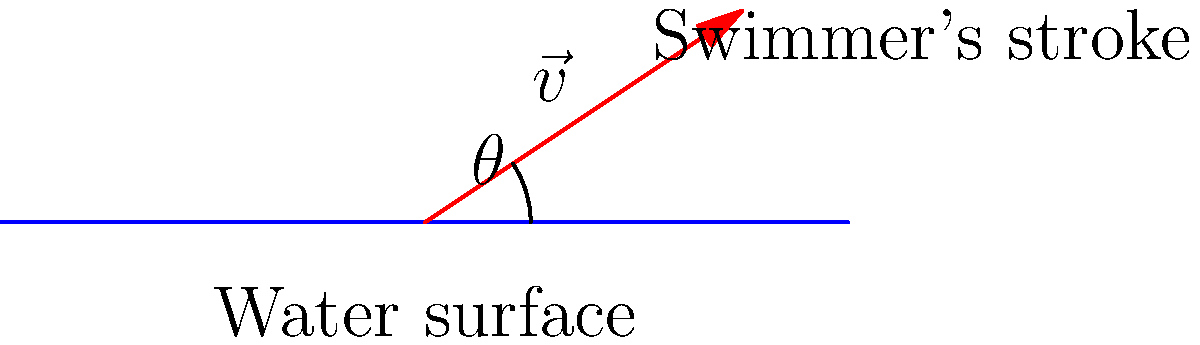A cancer survivor is advised to incorporate swimming into their exercise routine. To optimize their stroke efficiency, they need to determine the best angle and velocity for their arm movement. Given that the optimal angle for a swimming stroke is 45° to the water surface, and the recommended velocity magnitude is 2 m/s, what should be the velocity vector $\vec{v}$ in component form? Let's approach this step-by-step:

1) We know that the optimal angle $\theta$ is 45° to the water surface.

2) The velocity magnitude $|\vec{v}|$ is given as 2 m/s.

3) To find the velocity vector in component form, we need to calculate its x and y components:

   $v_x = |\vec{v}| \cos(\theta)$
   $v_y = |\vec{v}| \sin(\theta)$

4) For $\theta = 45°$:
   $\cos(45°) = \sin(45°) = \frac{1}{\sqrt{2}} \approx 0.707$

5) Now, let's calculate the components:

   $v_x = 2 \cdot \frac{1}{\sqrt{2}} = \frac{2}{\sqrt{2}} \approx 1.414$ m/s
   $v_y = 2 \cdot \frac{1}{\sqrt{2}} = \frac{2}{\sqrt{2}} \approx 1.414$ m/s

6) Therefore, the velocity vector in component form is:

   $\vec{v} = (\frac{2}{\sqrt{2}}, \frac{2}{\sqrt{2}})$ m/s

   or approximately $(1.414, 1.414)$ m/s
Answer: $\vec{v} = (\frac{2}{\sqrt{2}}, \frac{2}{\sqrt{2}})$ m/s 